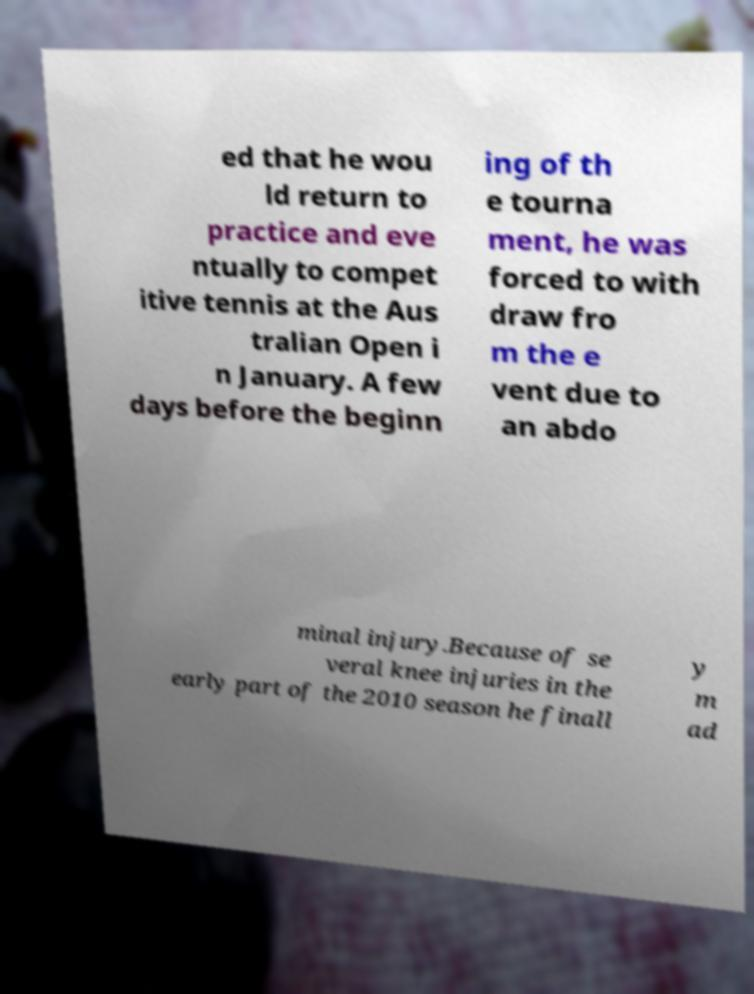Could you extract and type out the text from this image? ed that he wou ld return to practice and eve ntually to compet itive tennis at the Aus tralian Open i n January. A few days before the beginn ing of th e tourna ment, he was forced to with draw fro m the e vent due to an abdo minal injury.Because of se veral knee injuries in the early part of the 2010 season he finall y m ad 